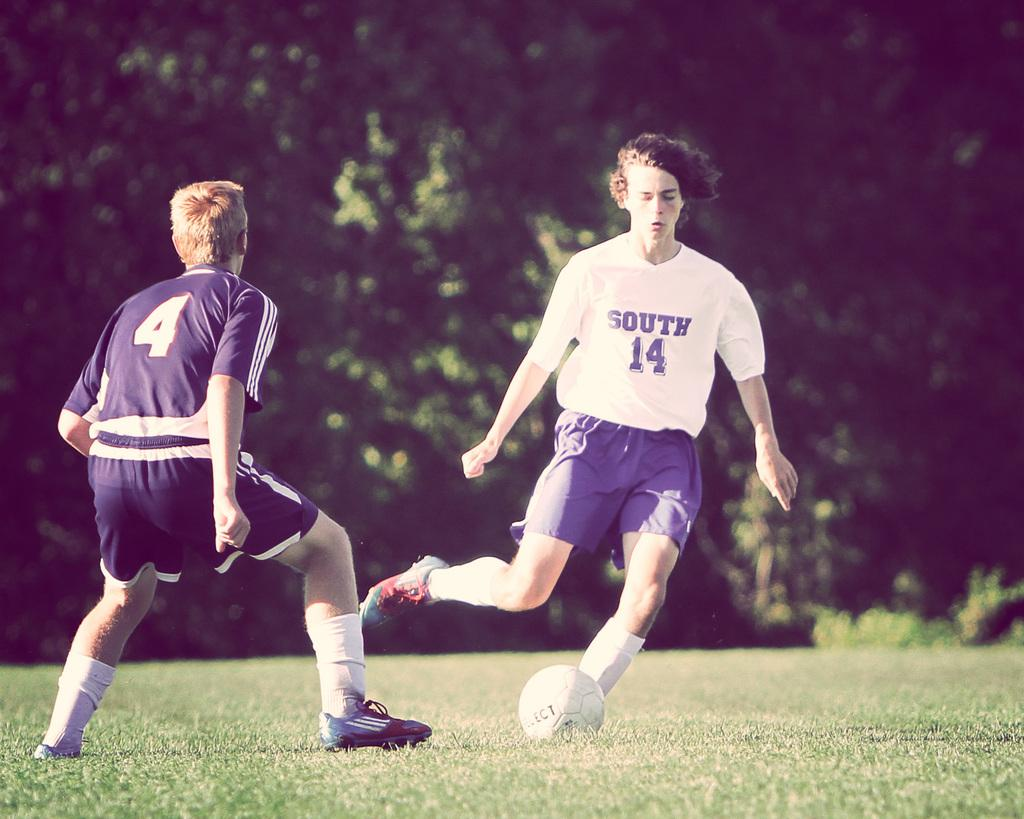<image>
Share a concise interpretation of the image provided. A soccer player is wearing a shirt with South and the number 14 on it. 